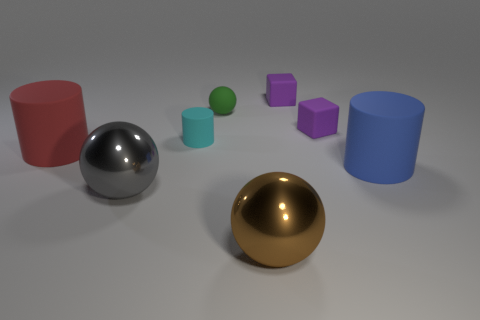What is the shape of the cyan matte thing? cylinder 